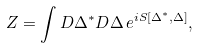<formula> <loc_0><loc_0><loc_500><loc_500>Z = \int D \Delta ^ { * } D \Delta \, e ^ { i S [ \Delta ^ { * } , \Delta ] } ,</formula> 